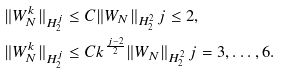<formula> <loc_0><loc_0><loc_500><loc_500>\| W _ { N } ^ { k } \| _ { H _ { 2 } ^ { j } } & \leq C \| W _ { N } \| _ { H _ { 2 } ^ { 2 } } \, j \leq 2 , \, \\ \| W _ { N } ^ { k } \| _ { H _ { 2 } ^ { j } } & \leq C k ^ { \frac { j - 2 } { 2 } } \| W _ { N } \| _ { H _ { 2 } ^ { 2 } } \, j = 3 , \dots , 6 .</formula> 